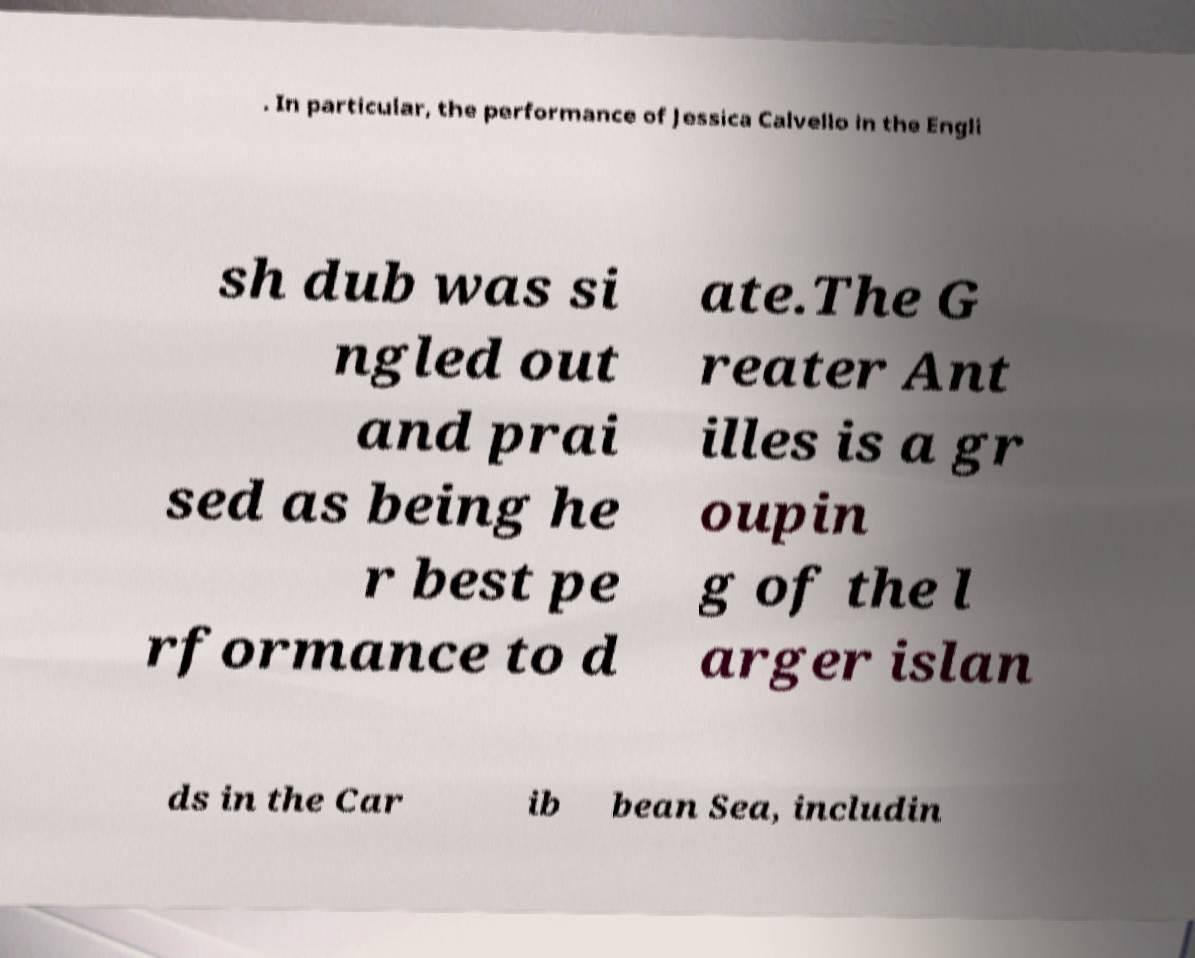What messages or text are displayed in this image? I need them in a readable, typed format. . In particular, the performance of Jessica Calvello in the Engli sh dub was si ngled out and prai sed as being he r best pe rformance to d ate.The G reater Ant illes is a gr oupin g of the l arger islan ds in the Car ib bean Sea, includin 